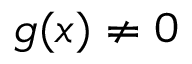<formula> <loc_0><loc_0><loc_500><loc_500>g ( x ) \neq 0</formula> 